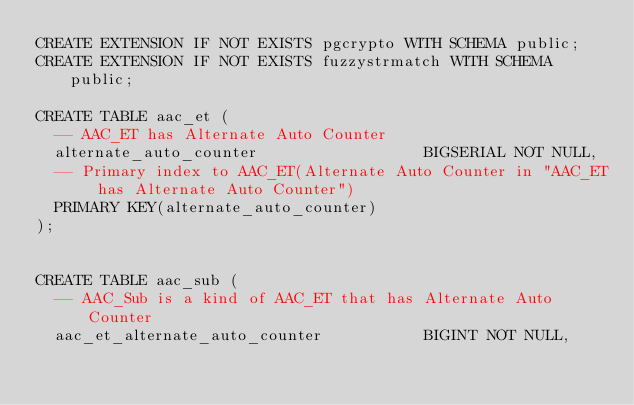Convert code to text. <code><loc_0><loc_0><loc_500><loc_500><_SQL_>CREATE EXTENSION IF NOT EXISTS pgcrypto WITH SCHEMA public;
CREATE EXTENSION IF NOT EXISTS fuzzystrmatch WITH SCHEMA public;

CREATE TABLE aac_et (
	-- AAC_ET has Alternate Auto Counter
	alternate_auto_counter                  BIGSERIAL NOT NULL,
	-- Primary index to AAC_ET(Alternate Auto Counter in "AAC_ET has Alternate Auto Counter")
	PRIMARY KEY(alternate_auto_counter)
);


CREATE TABLE aac_sub (
	-- AAC_Sub is a kind of AAC_ET that has Alternate Auto Counter
	aac_et_alternate_auto_counter           BIGINT NOT NULL,</code> 